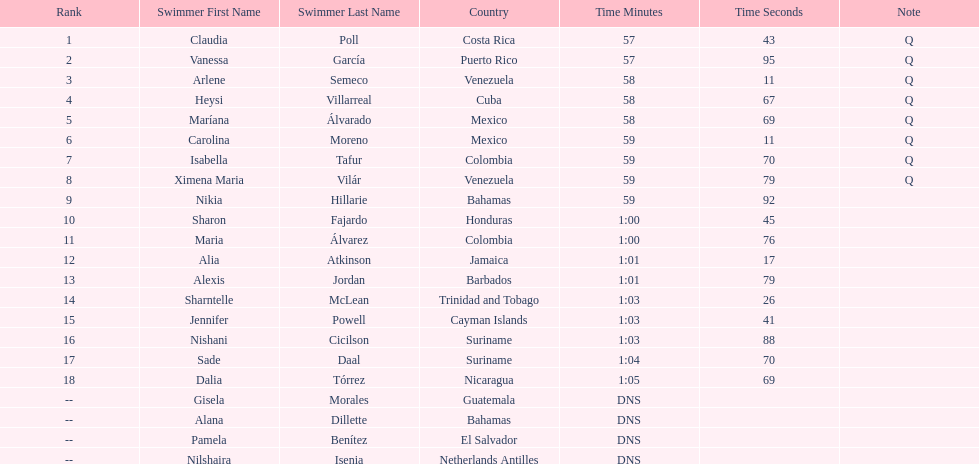Which swimmer had the longest time? Dalia Tórrez. 